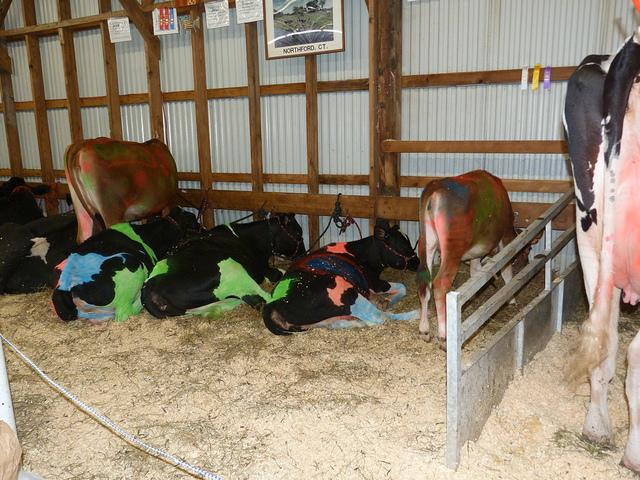What made the cows unnatural colors? paint 